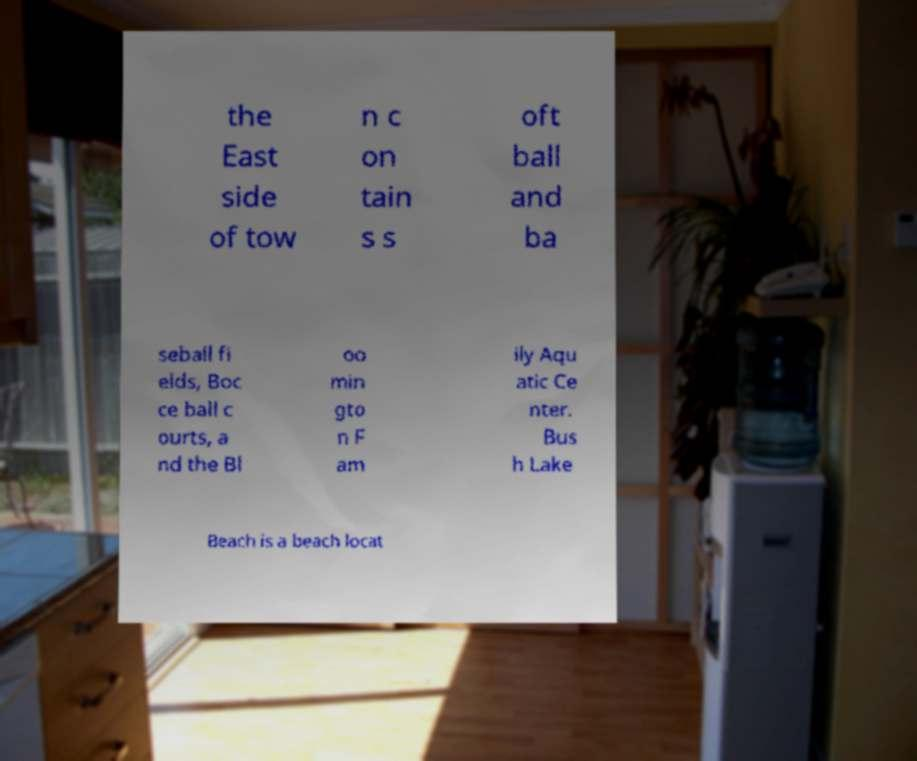Can you read and provide the text displayed in the image?This photo seems to have some interesting text. Can you extract and type it out for me? the East side of tow n c on tain s s oft ball and ba seball fi elds, Boc ce ball c ourts, a nd the Bl oo min gto n F am ily Aqu atic Ce nter. Bus h Lake Beach is a beach locat 